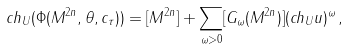<formula> <loc_0><loc_0><loc_500><loc_500>c h _ { U } ( \Phi ( M ^ { 2 n } , \theta , c _ { \tau } ) ) = [ M ^ { 2 n } ] + \sum _ { \| \omega \| > 0 } [ G _ { \omega } ( M ^ { 2 n } ) ] ( c h _ { U } { u } ) ^ { \omega } \, ,</formula> 